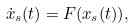Convert formula to latex. <formula><loc_0><loc_0><loc_500><loc_500>\dot { x } _ { s } ( t ) = F ( x _ { s } ( t ) ) ,</formula> 